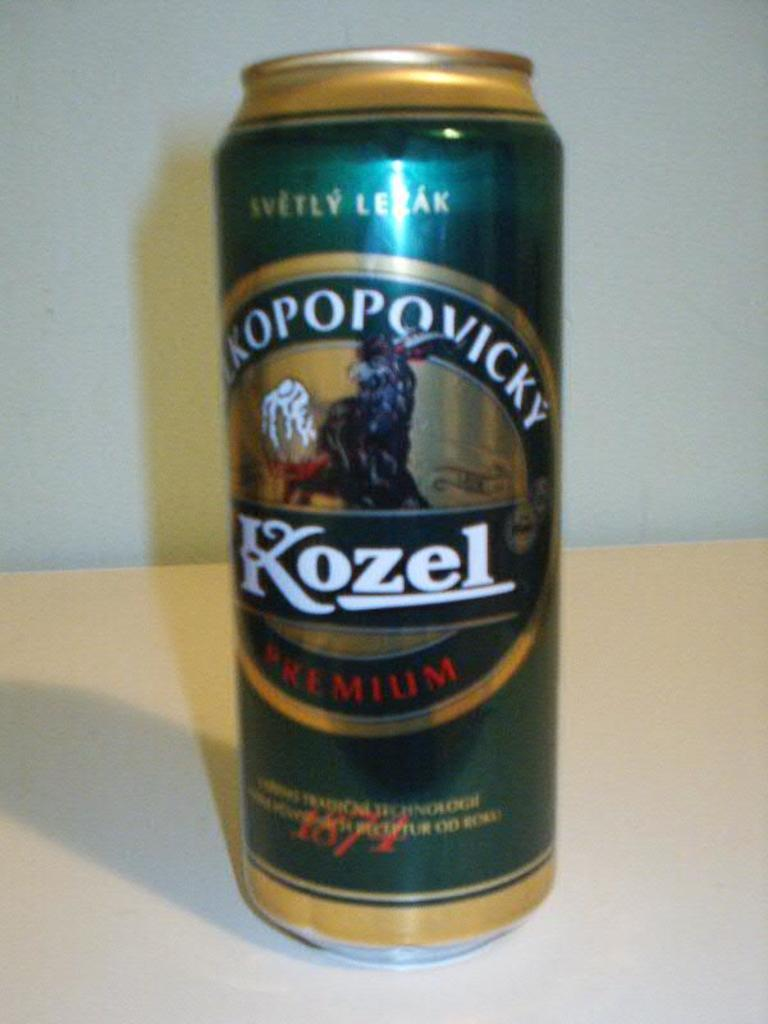<image>
Share a concise interpretation of the image provided. A can of Kozel Premium beer sitting on a white table. 